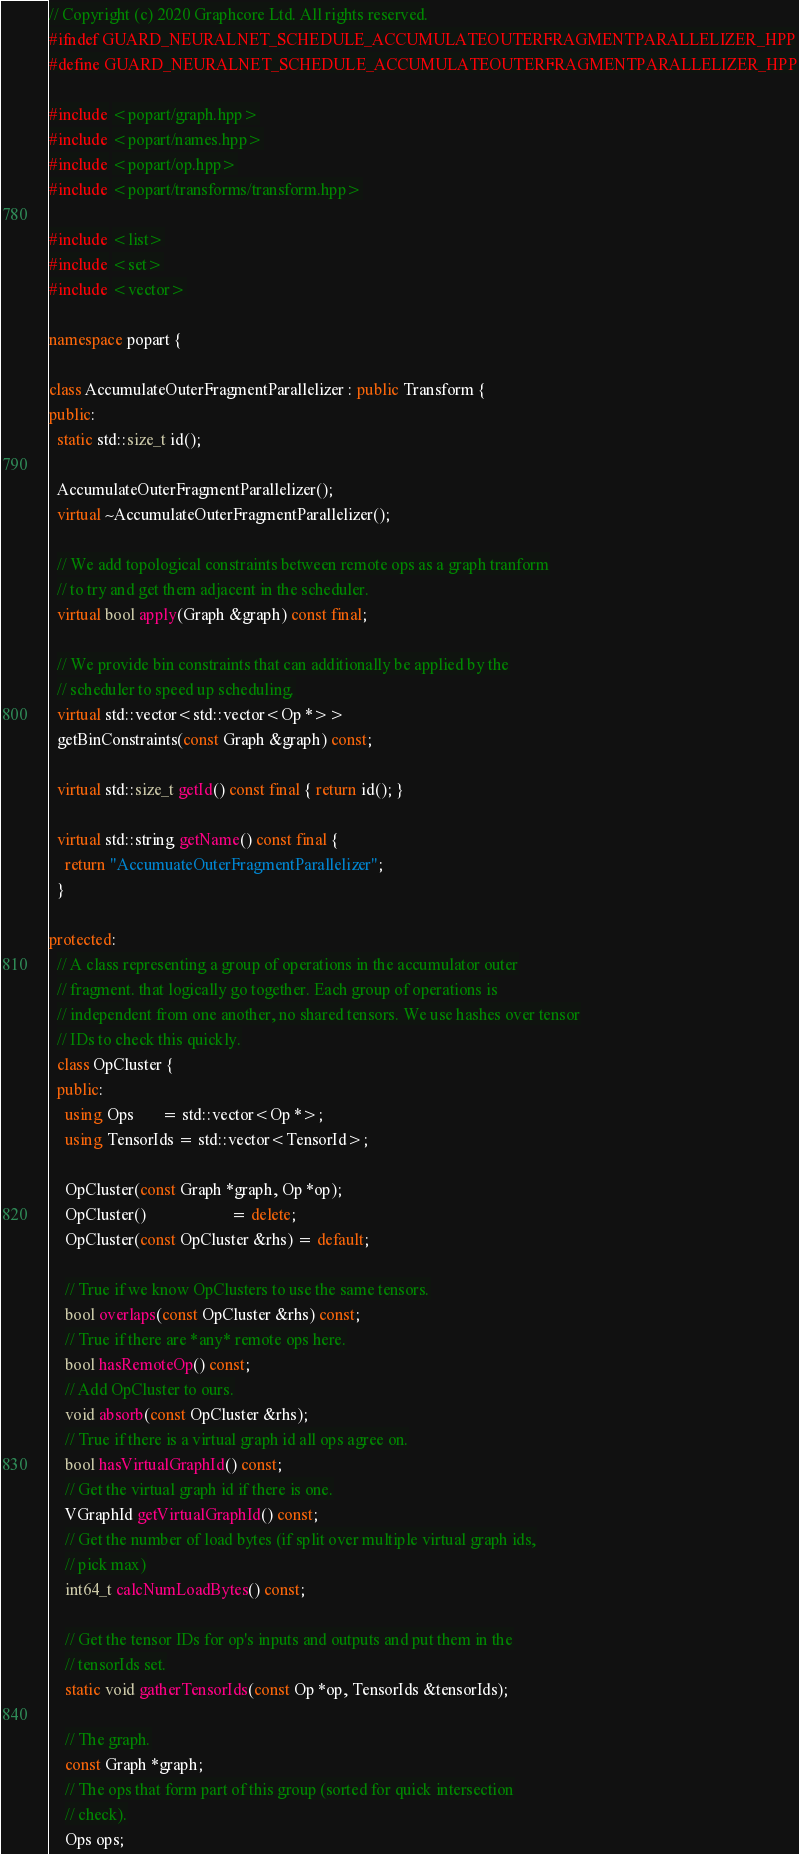Convert code to text. <code><loc_0><loc_0><loc_500><loc_500><_C++_>// Copyright (c) 2020 Graphcore Ltd. All rights reserved.
#ifndef GUARD_NEURALNET_SCHEDULE_ACCUMULATEOUTERFRAGMENTPARALLELIZER_HPP
#define GUARD_NEURALNET_SCHEDULE_ACCUMULATEOUTERFRAGMENTPARALLELIZER_HPP

#include <popart/graph.hpp>
#include <popart/names.hpp>
#include <popart/op.hpp>
#include <popart/transforms/transform.hpp>

#include <list>
#include <set>
#include <vector>

namespace popart {

class AccumulateOuterFragmentParallelizer : public Transform {
public:
  static std::size_t id();

  AccumulateOuterFragmentParallelizer();
  virtual ~AccumulateOuterFragmentParallelizer();

  // We add topological constraints between remote ops as a graph tranform
  // to try and get them adjacent in the scheduler.
  virtual bool apply(Graph &graph) const final;

  // We provide bin constraints that can additionally be applied by the
  // scheduler to speed up scheduling.
  virtual std::vector<std::vector<Op *>>
  getBinConstraints(const Graph &graph) const;

  virtual std::size_t getId() const final { return id(); }

  virtual std::string getName() const final {
    return "AccumuateOuterFragmentParallelizer";
  }

protected:
  // A class representing a group of operations in the accumulator outer
  // fragment. that logically go together. Each group of operations is
  // independent from one another, no shared tensors. We use hashes over tensor
  // IDs to check this quickly.
  class OpCluster {
  public:
    using Ops       = std::vector<Op *>;
    using TensorIds = std::vector<TensorId>;

    OpCluster(const Graph *graph, Op *op);
    OpCluster()                     = delete;
    OpCluster(const OpCluster &rhs) = default;

    // True if we know OpClusters to use the same tensors.
    bool overlaps(const OpCluster &rhs) const;
    // True if there are *any* remote ops here.
    bool hasRemoteOp() const;
    // Add OpCluster to ours.
    void absorb(const OpCluster &rhs);
    // True if there is a virtual graph id all ops agree on.
    bool hasVirtualGraphId() const;
    // Get the virtual graph id if there is one.
    VGraphId getVirtualGraphId() const;
    // Get the number of load bytes (if split over multiple virtual graph ids,
    // pick max)
    int64_t calcNumLoadBytes() const;

    // Get the tensor IDs for op's inputs and outputs and put them in the
    // tensorIds set.
    static void gatherTensorIds(const Op *op, TensorIds &tensorIds);

    // The graph.
    const Graph *graph;
    // The ops that form part of this group (sorted for quick intersection
    // check).
    Ops ops;</code> 